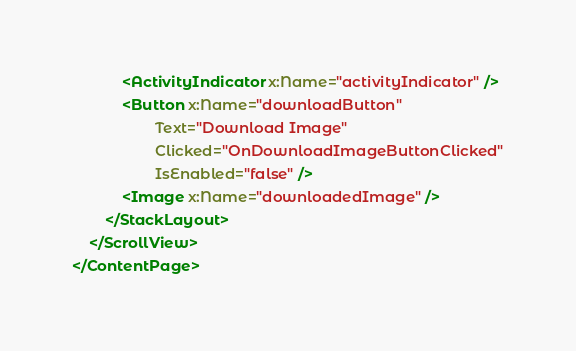Convert code to text. <code><loc_0><loc_0><loc_500><loc_500><_XML_>            <ActivityIndicator x:Name="activityIndicator" />
            <Button x:Name="downloadButton" 
                    Text="Download Image" 
                    Clicked="OnDownloadImageButtonClicked"
                    IsEnabled="false" />
            <Image x:Name="downloadedImage" />
        </StackLayout>
    </ScrollView>
</ContentPage>
</code> 